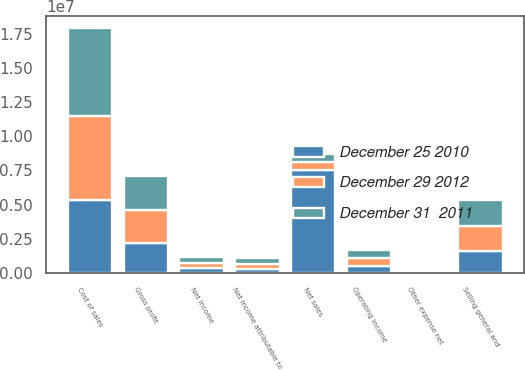<chart> <loc_0><loc_0><loc_500><loc_500><stacked_bar_chart><ecel><fcel>Net sales<fcel>Cost of sales<fcel>Gross profit<fcel>Selling general and<fcel>Operating income<fcel>Other expense net<fcel>Net income<fcel>Net income attributable to<nl><fcel>December 31  2011<fcel>600555<fcel>6.43245e+06<fcel>2.50751e+06<fcel>1.87336e+06<fcel>618961<fcel>14773<fcel>423388<fcel>388076<nl><fcel>December 29 2012<fcel>600555<fcel>6.11219e+06<fcel>2.41806e+06<fcel>1.83591e+06<fcel>582149<fcel>12842<fcel>404656<fcel>367661<nl><fcel>December 25 2010<fcel>7.52679e+06<fcel>5.35591e+06<fcel>2.17088e+06<fcel>1.63746e+06<fcel>521131<fcel>19096<fcel>352131<fcel>325789<nl></chart> 